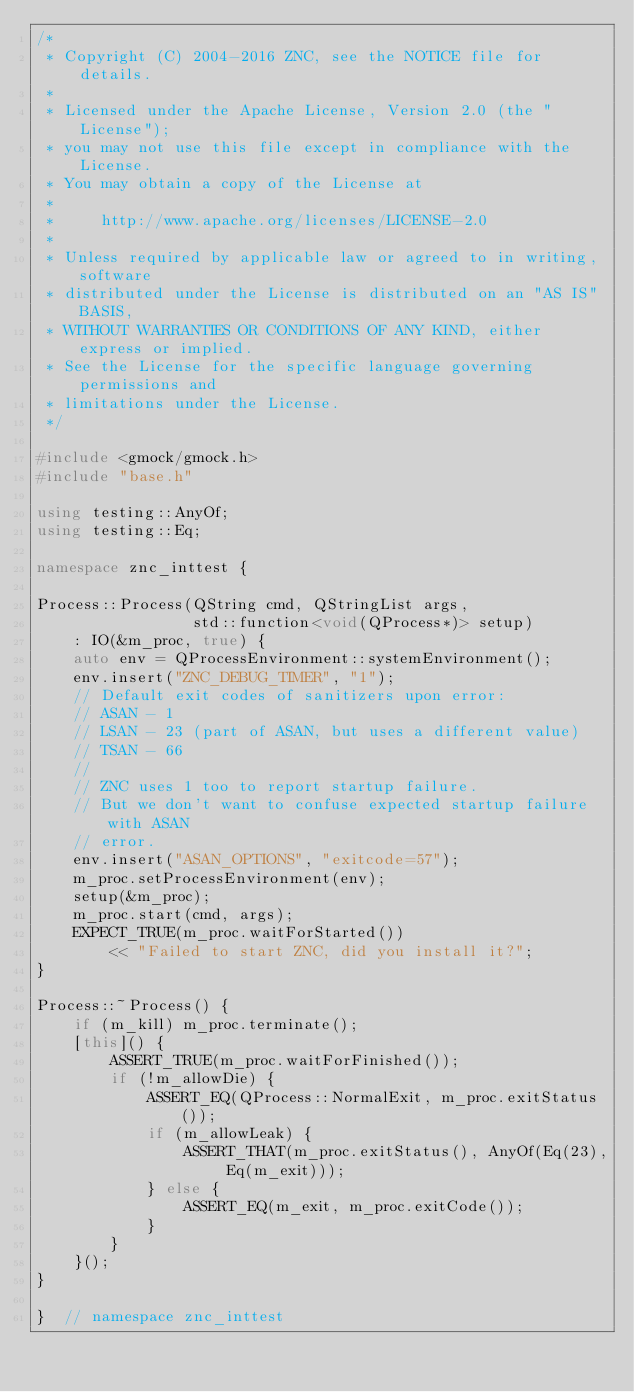<code> <loc_0><loc_0><loc_500><loc_500><_C++_>/*
 * Copyright (C) 2004-2016 ZNC, see the NOTICE file for details.
 *
 * Licensed under the Apache License, Version 2.0 (the "License");
 * you may not use this file except in compliance with the License.
 * You may obtain a copy of the License at
 *
 *     http://www.apache.org/licenses/LICENSE-2.0
 *
 * Unless required by applicable law or agreed to in writing, software
 * distributed under the License is distributed on an "AS IS" BASIS,
 * WITHOUT WARRANTIES OR CONDITIONS OF ANY KIND, either express or implied.
 * See the License for the specific language governing permissions and
 * limitations under the License.
 */

#include <gmock/gmock.h>
#include "base.h"

using testing::AnyOf;
using testing::Eq;

namespace znc_inttest {

Process::Process(QString cmd, QStringList args,
                 std::function<void(QProcess*)> setup)
    : IO(&m_proc, true) {
    auto env = QProcessEnvironment::systemEnvironment();
    env.insert("ZNC_DEBUG_TIMER", "1");
    // Default exit codes of sanitizers upon error:
    // ASAN - 1
    // LSAN - 23 (part of ASAN, but uses a different value)
    // TSAN - 66
    //
    // ZNC uses 1 too to report startup failure.
    // But we don't want to confuse expected startup failure with ASAN
    // error.
    env.insert("ASAN_OPTIONS", "exitcode=57");
    m_proc.setProcessEnvironment(env);
    setup(&m_proc);
    m_proc.start(cmd, args);
    EXPECT_TRUE(m_proc.waitForStarted())
        << "Failed to start ZNC, did you install it?";
}

Process::~Process() {
    if (m_kill) m_proc.terminate();
    [this]() {
        ASSERT_TRUE(m_proc.waitForFinished());
        if (!m_allowDie) {
            ASSERT_EQ(QProcess::NormalExit, m_proc.exitStatus());
            if (m_allowLeak) {
                ASSERT_THAT(m_proc.exitStatus(), AnyOf(Eq(23), Eq(m_exit)));
            } else {
                ASSERT_EQ(m_exit, m_proc.exitCode());
            }
        }
    }();
}

}  // namespace znc_inttest
</code> 